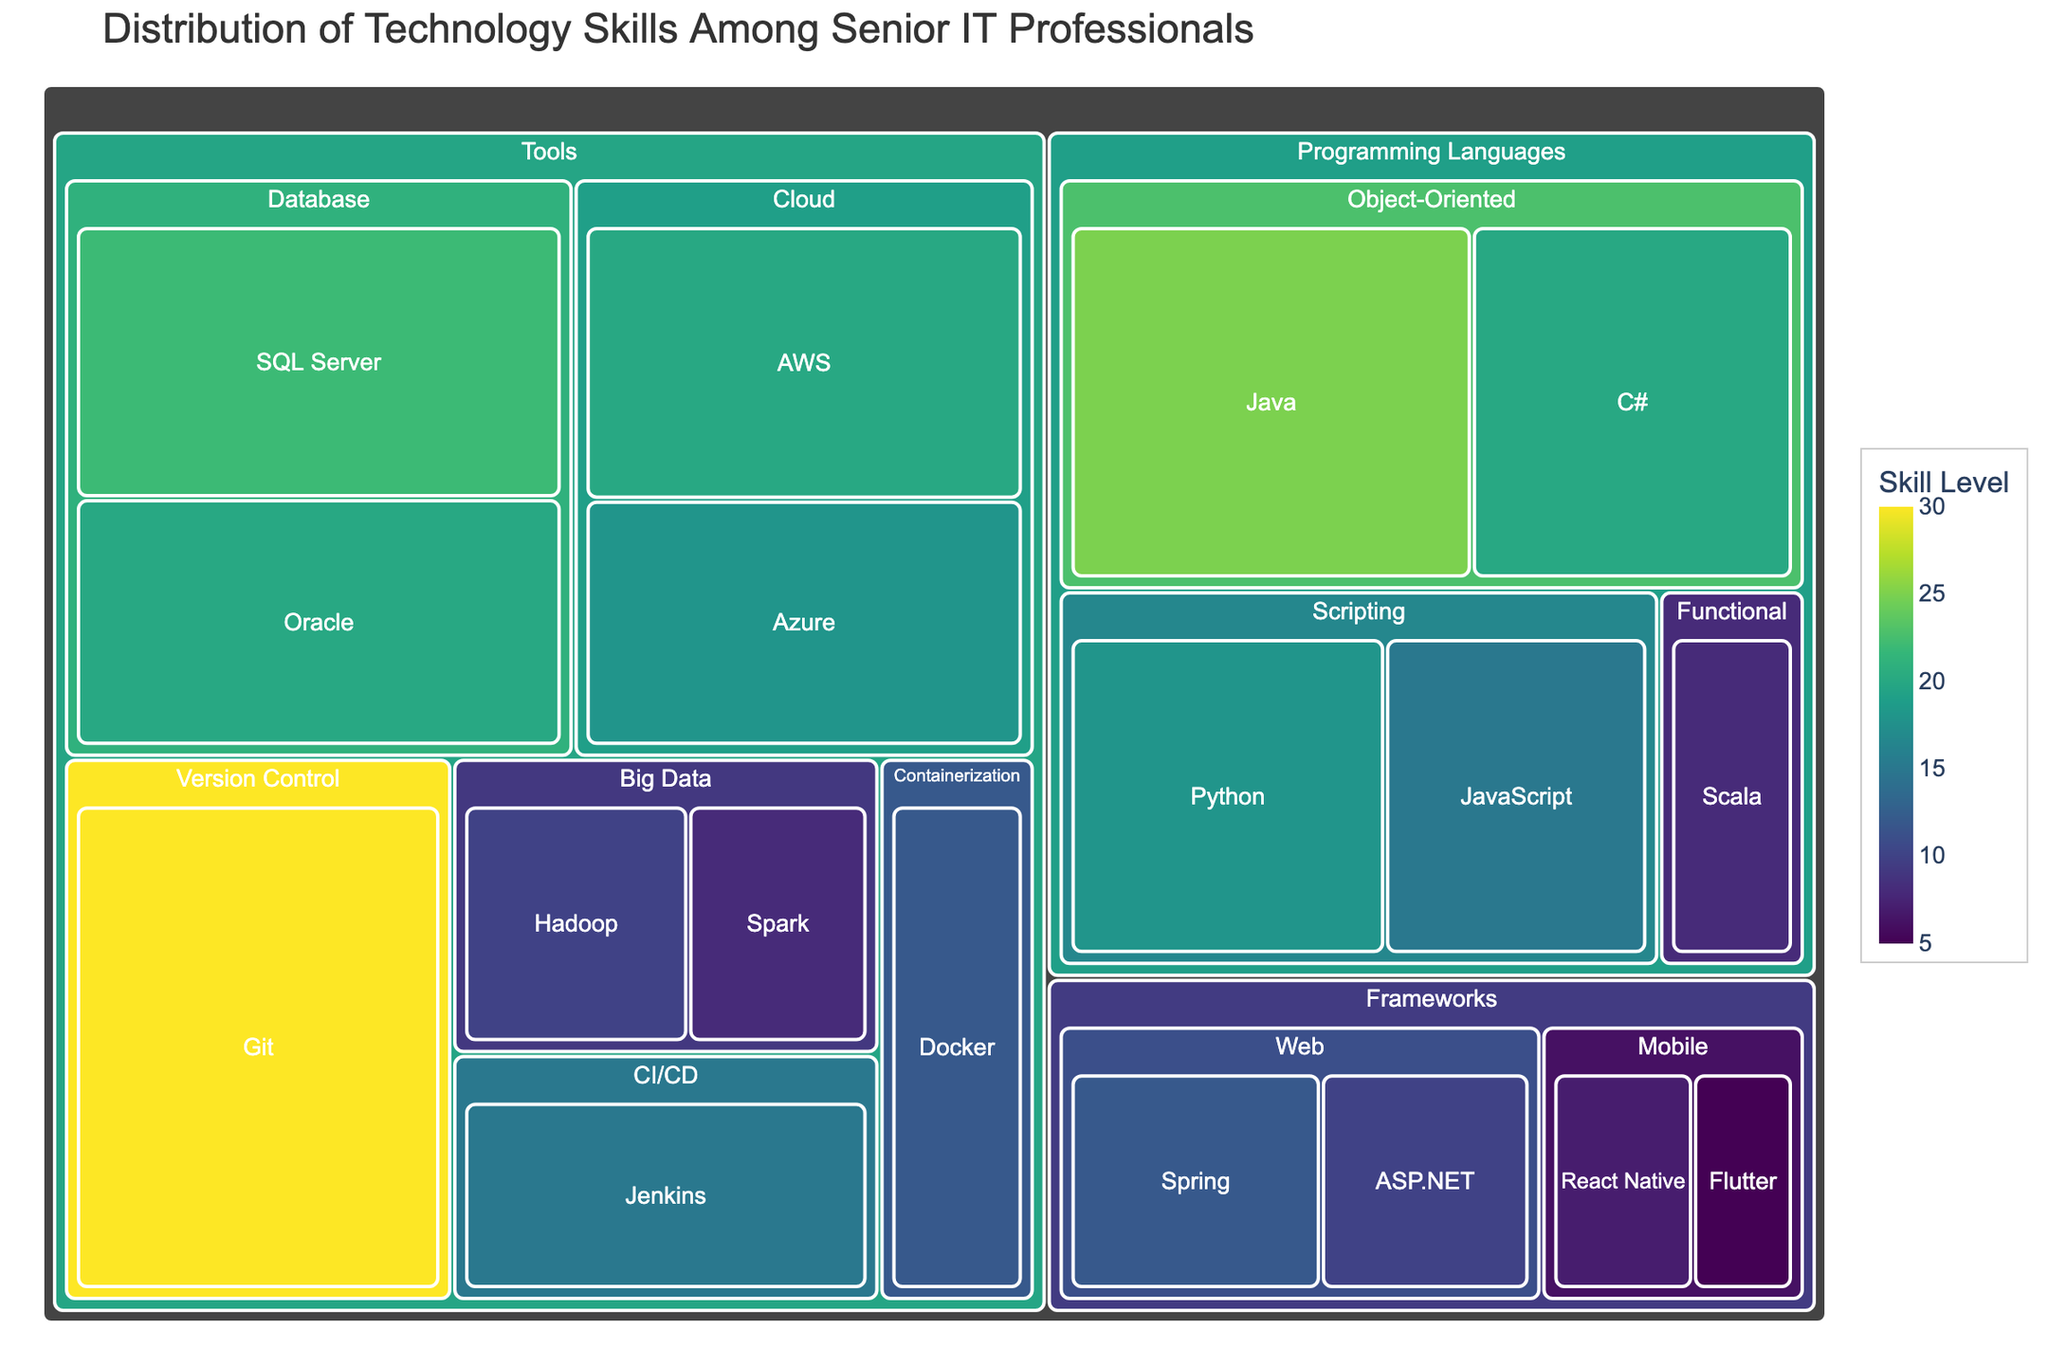Which category has the highest overall value? The category "Tools" has the highest overall value. In a treemap, larger areas represent higher values. The Tools section is the largest one.
Answer: Tools What is the title of the figure? The title of the figure is "Distribution of Technology Skills Among Senior IT Professionals". You can see this clearly at the top of the treemap.
Answer: Distribution of Technology Skills Among Senior IT Professionals Which skill under Programming Languages has the lowest value? You need to look under the Programming Languages section and identify the smallest tile. "Scala" under the Functional subcategory has the smallest value.
Answer: Scala What is the combined value of the "Cloud" subcategory under Tools? To get the combined value, add the values of AWS (20) and Azure (18). The sum is 20 + 18 = 38.
Answer: 38 How does the value of Git compare to that of Jenkins? Check the sizes of the tiles for Git and Jenkins under the Tools category. Git has a value of 30, while Jenkins has a value of 15. So, Git has a higher value.
Answer: Git has a higher value Which subcategory under Frameworks has the highest value? Look for the largest tile within the Frameworks category. The Web subcategory has tiles for Spring (12) and ASP.NET (10), summing to 22, which is larger than the sums for the Mobile subcategory.
Answer: Web Are there more senior IT professionals skilled in Python or JavaScript? In the treemap, each programming language's tile size indicates the number of professionals. Look for Python and JavaScript under Scripting. Python has a value of 18 and JavaScript has 15. Python has more professionals.
Answer: Python What is the second most common skill under the Tools category? The most common skill is Git with 30. The second most common would be the one with the next highest value, which is SQL Server with 22.
Answer: SQL Server Which subcategory in Tools has the smallest total value? Add up the values within each subcategory under Tools. Big Data has a sum of 18 (Hadoop 10 + Spark 8), the smallest compared to other subcategories.
Answer: Big Data How does the value of React Native compare to the total value of all Functional Programming Languages? First, find the value of React Native (7). Then, add the values of all Functional Programming Languages, which is just Scala with 8. Compare 7 to 8.
Answer: Functional Programming Languages have a higher value 